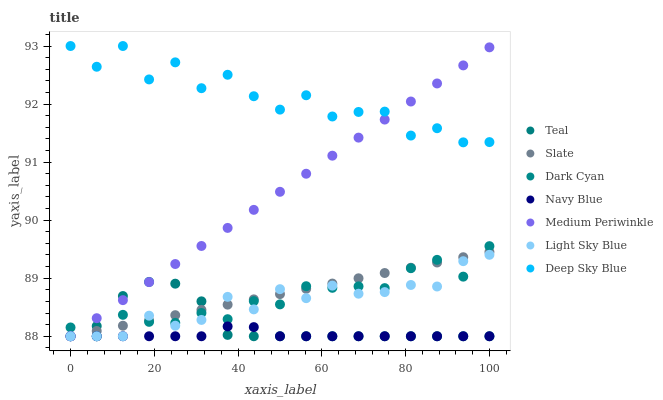Does Navy Blue have the minimum area under the curve?
Answer yes or no. Yes. Does Deep Sky Blue have the maximum area under the curve?
Answer yes or no. Yes. Does Slate have the minimum area under the curve?
Answer yes or no. No. Does Slate have the maximum area under the curve?
Answer yes or no. No. Is Slate the smoothest?
Answer yes or no. Yes. Is Deep Sky Blue the roughest?
Answer yes or no. Yes. Is Navy Blue the smoothest?
Answer yes or no. No. Is Navy Blue the roughest?
Answer yes or no. No. Does Navy Blue have the lowest value?
Answer yes or no. Yes. Does Deep Sky Blue have the highest value?
Answer yes or no. Yes. Does Slate have the highest value?
Answer yes or no. No. Is Light Sky Blue less than Deep Sky Blue?
Answer yes or no. Yes. Is Deep Sky Blue greater than Slate?
Answer yes or no. Yes. Does Teal intersect Navy Blue?
Answer yes or no. Yes. Is Teal less than Navy Blue?
Answer yes or no. No. Is Teal greater than Navy Blue?
Answer yes or no. No. Does Light Sky Blue intersect Deep Sky Blue?
Answer yes or no. No. 